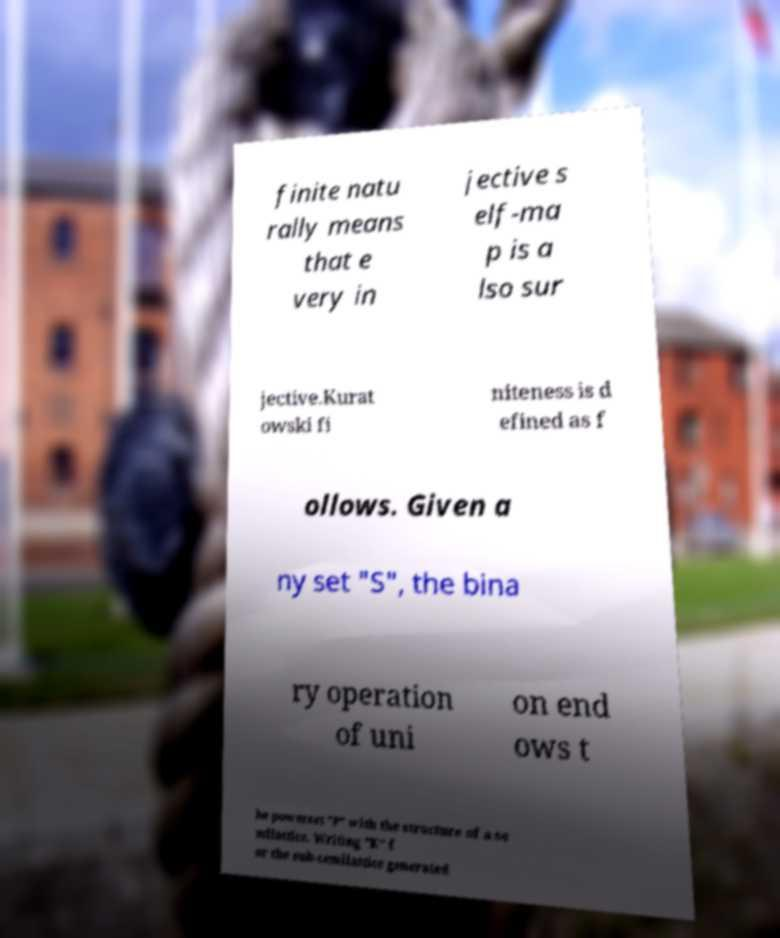Please read and relay the text visible in this image. What does it say? finite natu rally means that e very in jective s elf-ma p is a lso sur jective.Kurat owski fi niteness is d efined as f ollows. Given a ny set "S", the bina ry operation of uni on end ows t he powerset "P" with the structure of a se milattice. Writing "K" f or the sub-semilattice generated 